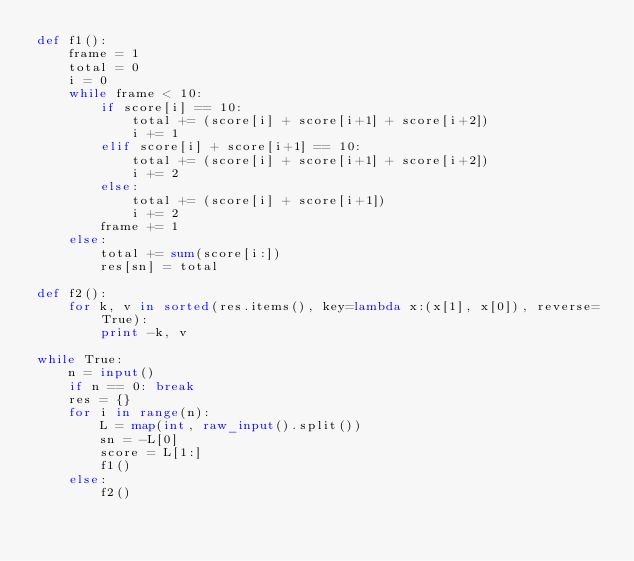Convert code to text. <code><loc_0><loc_0><loc_500><loc_500><_Python_>def f1():
    frame = 1
    total = 0
    i = 0
    while frame < 10:
        if score[i] == 10:
            total += (score[i] + score[i+1] + score[i+2])
            i += 1
        elif score[i] + score[i+1] == 10:
            total += (score[i] + score[i+1] + score[i+2])
            i += 2
        else:
            total += (score[i] + score[i+1])
            i += 2
        frame += 1
    else:
        total += sum(score[i:])
        res[sn] = total

def f2():
    for k, v in sorted(res.items(), key=lambda x:(x[1], x[0]), reverse=True):
        print -k, v

while True:
    n = input()
    if n == 0: break
    res = {}
    for i in range(n):
        L = map(int, raw_input().split())
        sn = -L[0]
        score = L[1:]
        f1()
    else:
        f2()</code> 